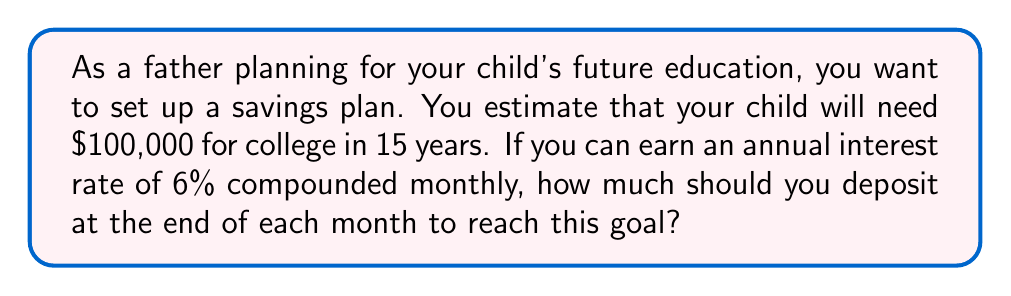Help me with this question. To solve this problem, we'll use the future value of an annuity formula:

$$FV = PMT \cdot \frac{(1 + \frac{r}{n})^{nt} - 1}{\frac{r}{n}}$$

Where:
$FV$ = Future Value ($100,000)
$PMT$ = Monthly Payment (what we're solving for)
$r$ = Annual Interest Rate (6% = 0.06)
$n$ = Number of Compounding Periods per Year (12 for monthly)
$t$ = Number of Years (15)

1) First, let's substitute the known values:

   $$100,000 = PMT \cdot \frac{(1 + \frac{0.06}{12})^{12 \cdot 15} - 1}{\frac{0.06}{12}}$$

2) Simplify the exponent:

   $$100,000 = PMT \cdot \frac{(1 + 0.005)^{180} - 1}{0.005}$$

3) Calculate the value inside the parentheses:

   $$100,000 = PMT \cdot \frac{2.4568 - 1}{0.005} = PMT \cdot 291.36$$

4) Solve for PMT:

   $$PMT = \frac{100,000}{291.36} = 343.22$$

Therefore, you need to deposit $343.22 at the end of each month to reach your goal.
Answer: $343.22 per month 